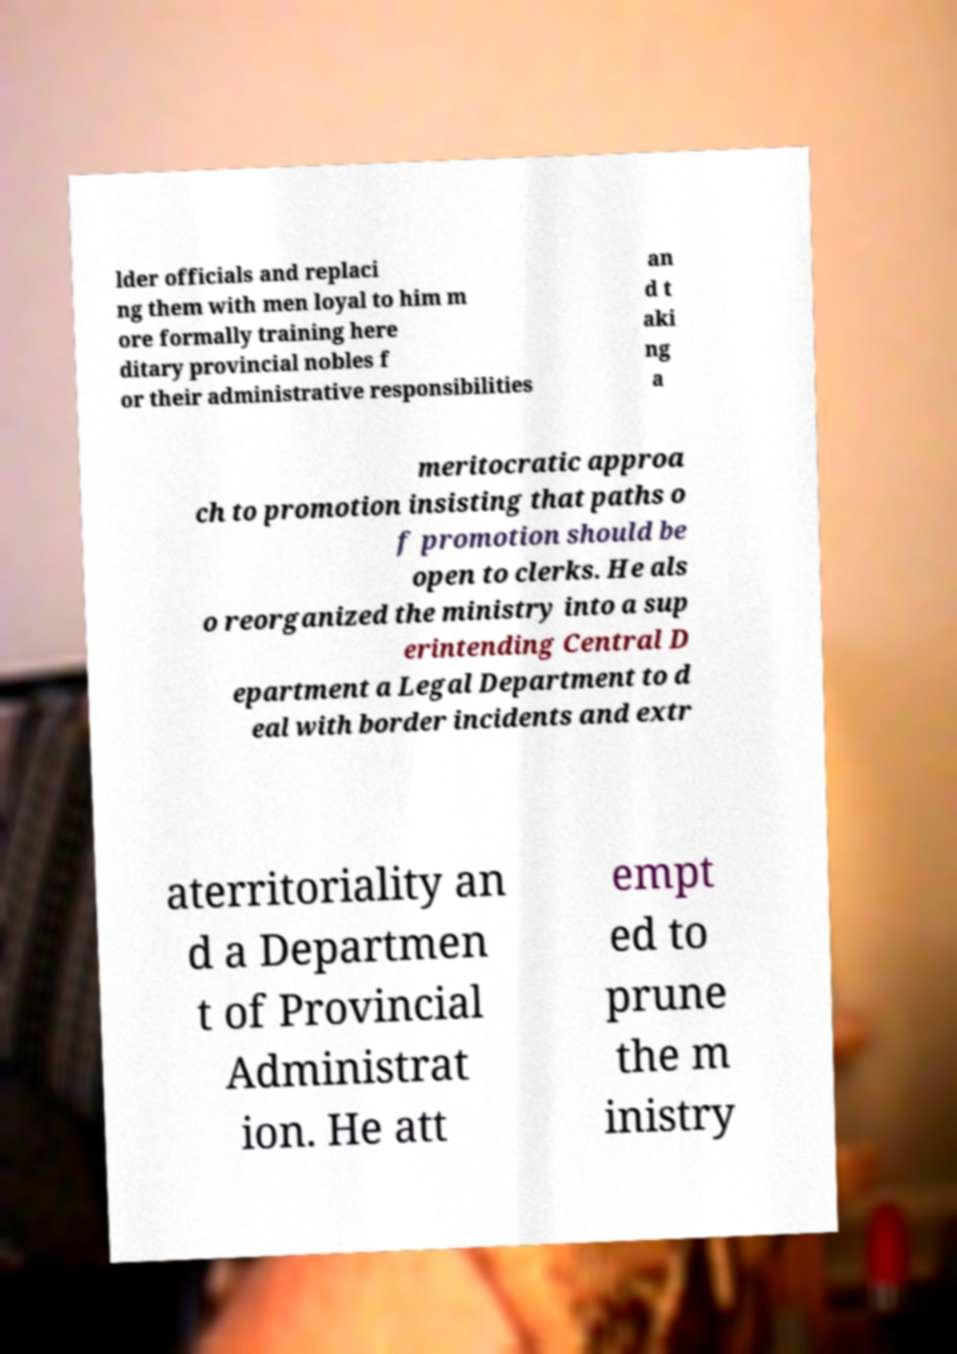I need the written content from this picture converted into text. Can you do that? lder officials and replaci ng them with men loyal to him m ore formally training here ditary provincial nobles f or their administrative responsibilities an d t aki ng a meritocratic approa ch to promotion insisting that paths o f promotion should be open to clerks. He als o reorganized the ministry into a sup erintending Central D epartment a Legal Department to d eal with border incidents and extr aterritoriality an d a Departmen t of Provincial Administrat ion. He att empt ed to prune the m inistry 